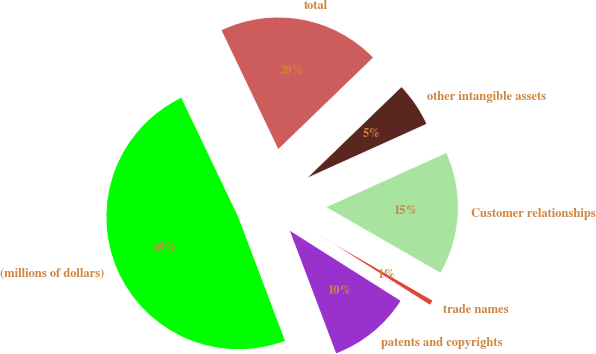<chart> <loc_0><loc_0><loc_500><loc_500><pie_chart><fcel>(millions of dollars)<fcel>patents and copyrights<fcel>trade names<fcel>Customer relationships<fcel>other intangible assets<fcel>total<nl><fcel>48.66%<fcel>10.27%<fcel>0.67%<fcel>15.07%<fcel>5.47%<fcel>19.87%<nl></chart> 